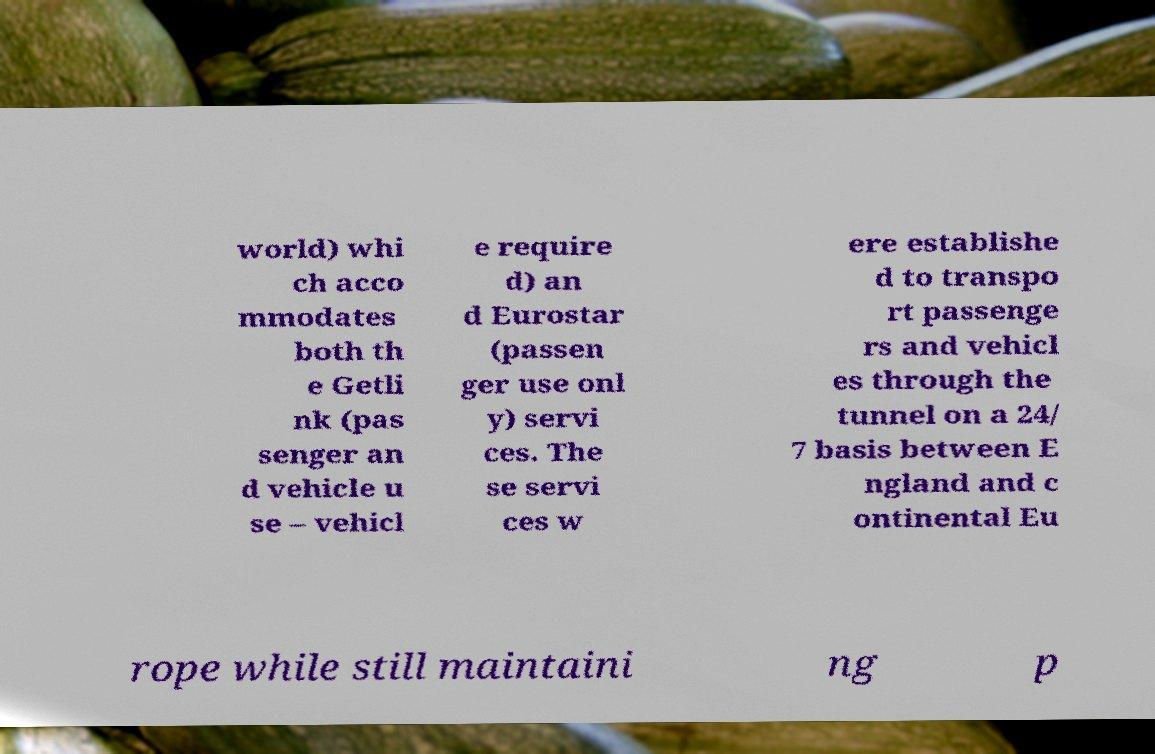Can you accurately transcribe the text from the provided image for me? world) whi ch acco mmodates both th e Getli nk (pas senger an d vehicle u se – vehicl e require d) an d Eurostar (passen ger use onl y) servi ces. The se servi ces w ere establishe d to transpo rt passenge rs and vehicl es through the tunnel on a 24/ 7 basis between E ngland and c ontinental Eu rope while still maintaini ng p 